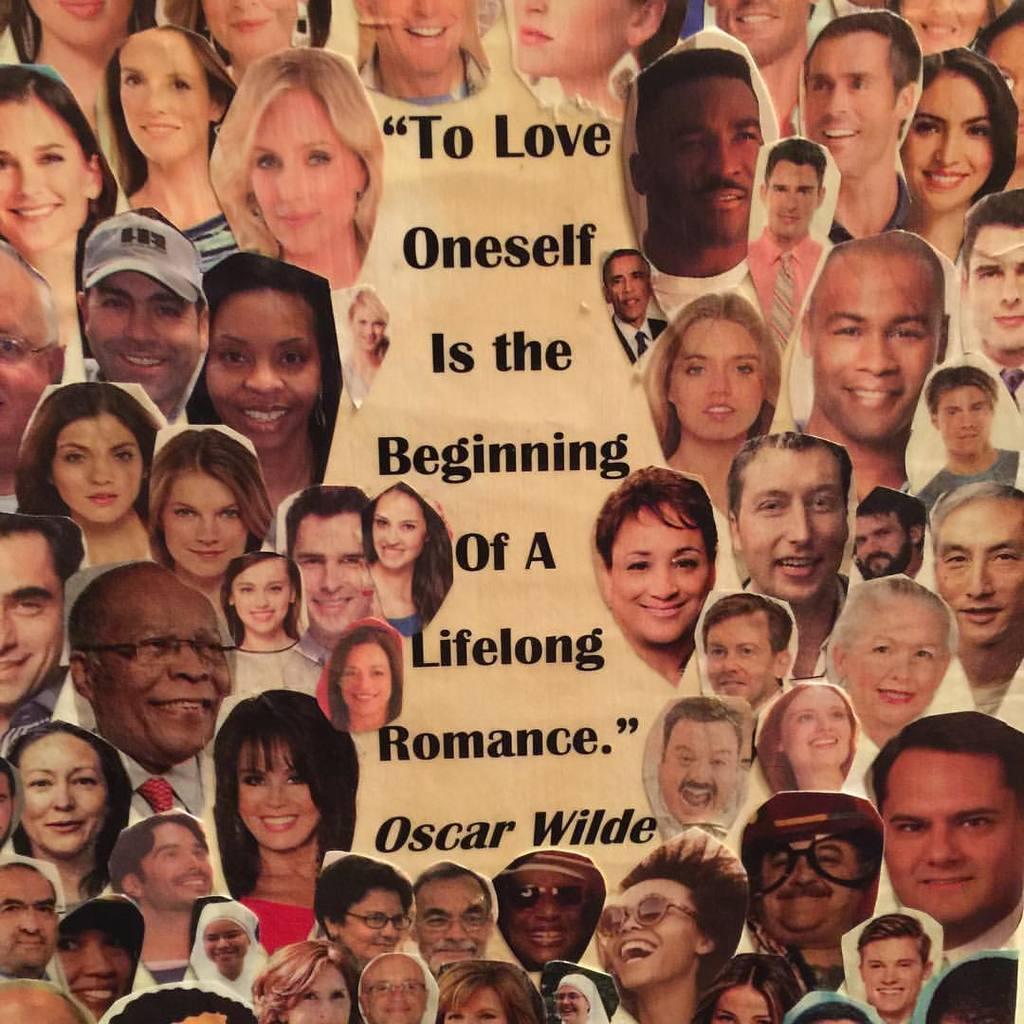In one or two sentences, can you explain what this image depicts? This is a poster. In this picture we can see a group of people and text. 